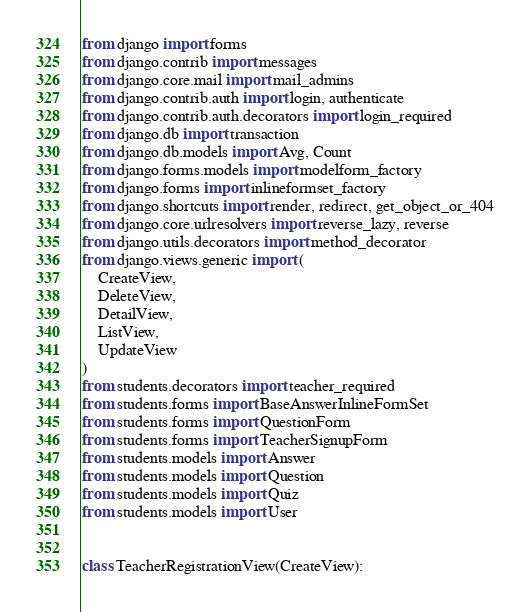<code> <loc_0><loc_0><loc_500><loc_500><_Python_>from django import forms
from django.contrib import messages
from django.core.mail import mail_admins
from django.contrib.auth import login, authenticate
from django.contrib.auth.decorators import login_required
from django.db import transaction
from django.db.models import Avg, Count
from django.forms.models import modelform_factory
from django.forms import inlineformset_factory
from django.shortcuts import render, redirect, get_object_or_404
from django.core.urlresolvers import reverse_lazy, reverse
from django.utils.decorators import method_decorator
from django.views.generic import (
    CreateView,
    DeleteView,
    DetailView,
    ListView,
    UpdateView
)
from students.decorators import teacher_required
from students.forms import BaseAnswerInlineFormSet
from students.forms import QuestionForm
from students.forms import TeacherSignupForm
from students.models import Answer
from students.models import Question
from students.models import Quiz
from students.models import User


class TeacherRegistrationView(CreateView):</code> 